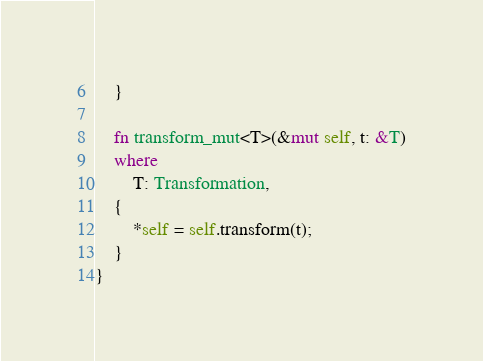<code> <loc_0><loc_0><loc_500><loc_500><_Rust_>    }

    fn transform_mut<T>(&mut self, t: &T)
    where
        T: Transformation,
    {
        *self = self.transform(t);
    }
}
</code> 